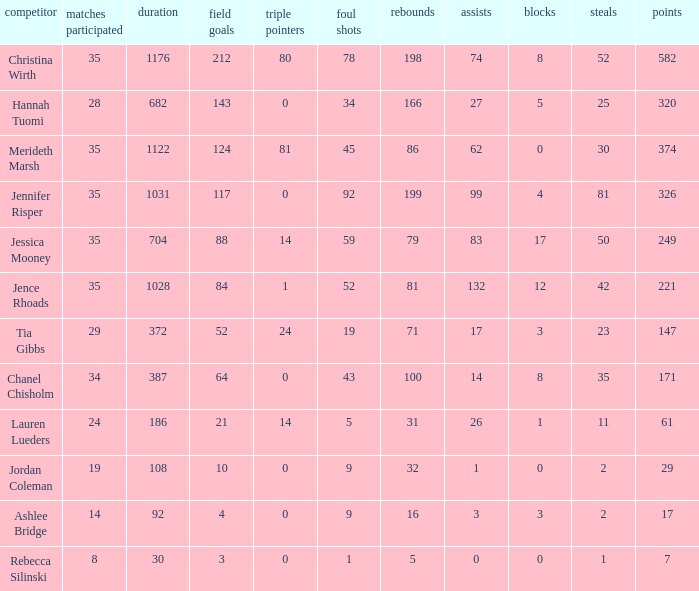For how long did Jordan Coleman play? 108.0. 